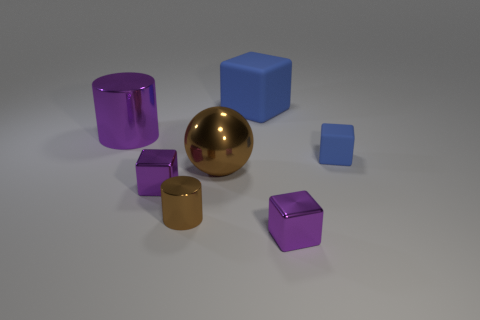Add 1 big brown balls. How many objects exist? 8 Subtract all cylinders. How many objects are left? 5 Add 3 small blue things. How many small blue things exist? 4 Subtract 0 gray blocks. How many objects are left? 7 Subtract all large green metallic blocks. Subtract all brown metal things. How many objects are left? 5 Add 3 big brown metal spheres. How many big brown metal spheres are left? 4 